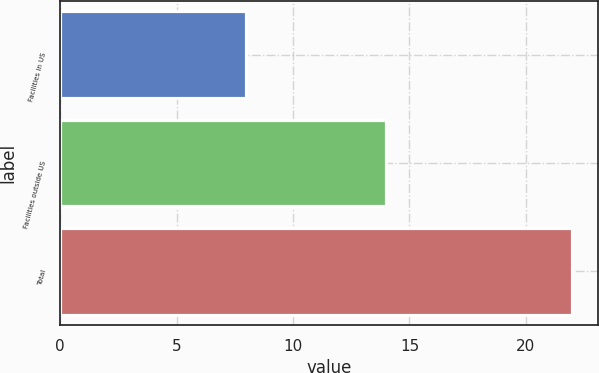Convert chart to OTSL. <chart><loc_0><loc_0><loc_500><loc_500><bar_chart><fcel>Facilities in US<fcel>Facilities outside US<fcel>Total<nl><fcel>8<fcel>14<fcel>22<nl></chart> 